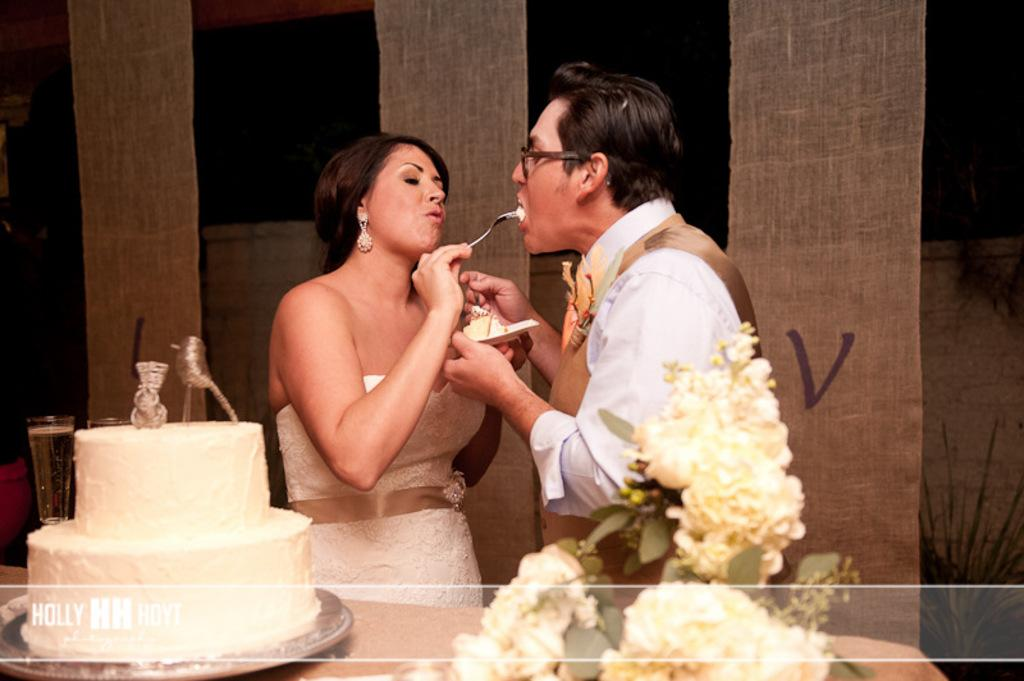Who is the main subject in the image? There is a woman standing in the middle of the image. What is located at the bottom of the image? There is a cake and flowers at the bottom of the image. What can be seen in the background of the image? There is a wall and pillars in the background of the image. What type of skate is being used by the woman in the image? There is no skate present in the image; the woman is standing. What memories does the woman have of the event depicted in the image? The image does not provide any information about the woman's memories or the event depicted. 